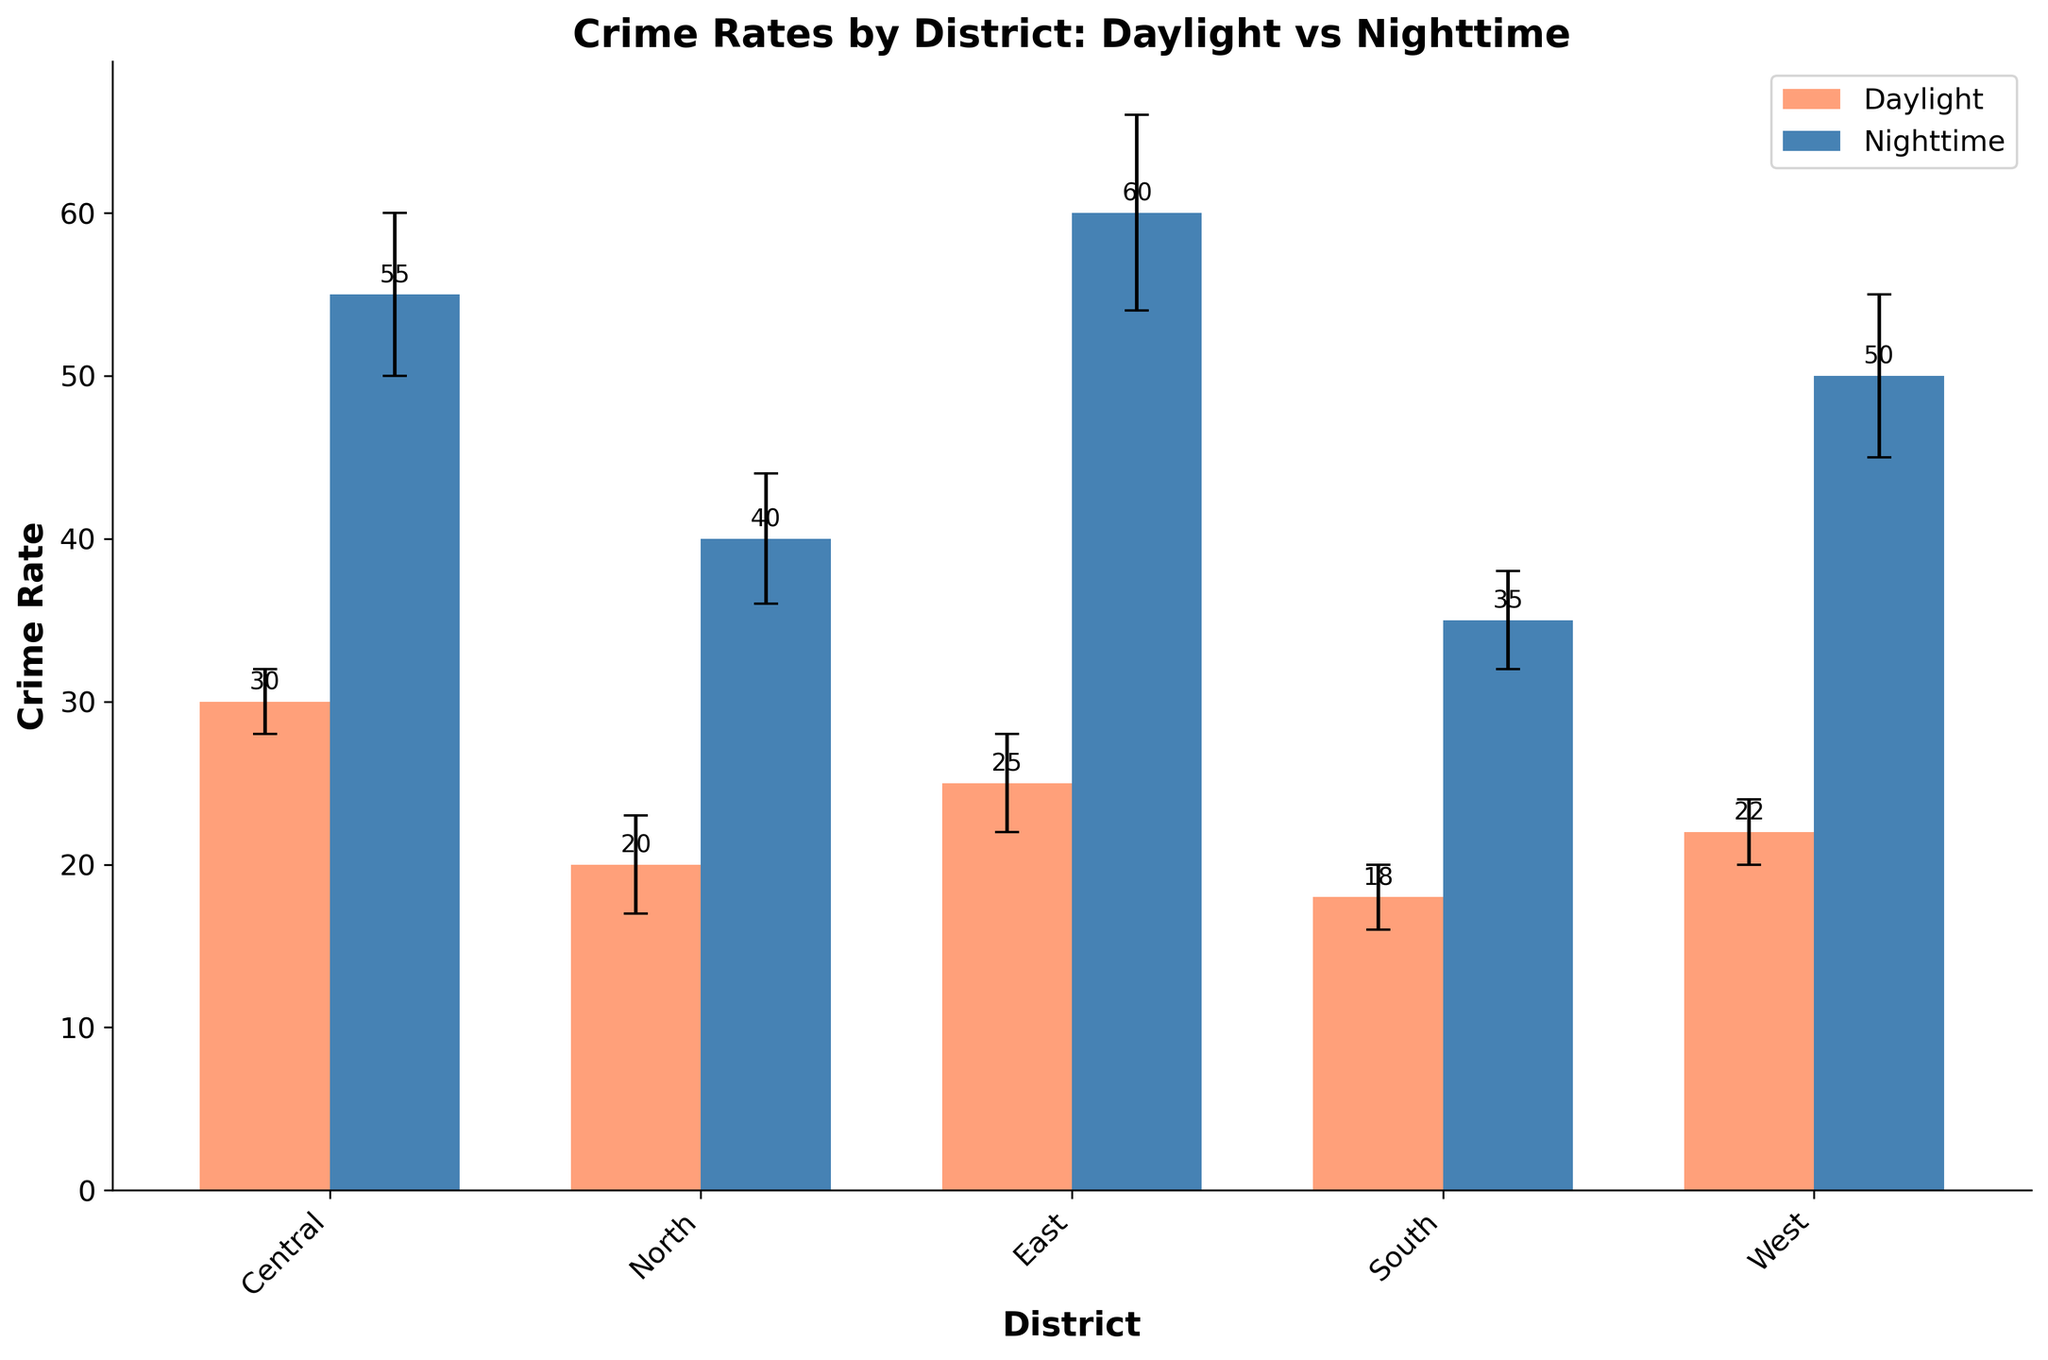What is the title of the plot? The title is often located at the top of the plot and summarizes the main objective of the data visualization. Here, it reads "Crime Rates by District: Daylight vs Nighttime".
Answer: Crime Rates by District: Daylight vs Nighttime Which district has the highest nighttime crime rate? To find the district with the highest nighttime crime rate, look at the tallest blue bar. The highest blue bar corresponds to the East district with a crime rate of 60.
Answer: East What is the range of error for the daytime crime rate in the West district? The error range for each bar can be seen by examining the error bars extending above and below the top of the bar. For the West district during the day, the error is ±2.
Answer: ±2 How many districts have higher nighttime crime rates compared to daylight crime rates? To determine the number of districts with higher nighttime crime rates, compare each pair of orange and blue bars. All districts (Central, North, East, South, and West) have higher nighttime rates.
Answer: 5 What is the total crime rate for the Central district, combining both day and night? Sum the crime rates for the Central district during the day and night: 30 (daylight) + 55 (nighttime) = 85.
Answer: 85 Which district has the smallest difference between daylight and nighttime crime rates? Calculate the differences between the day and night crime rates for all districts and find the smallest difference. For North: 40-20=20, for Central: 55-30=25, for South: 35-18=17, for East: 60-25=35, and for West: 50-22=28. The South district has the smallest difference of 17.
Answer: South Among the districts, which one has the highest error in nighttime crime rates? Look at the length of the error bars for the nighttime crime rates (blue bars) and compare them. The East district has the highest error of ±6.
Answer: East What is the average crime rate during the daytime across all districts? Calculate the average of the daytime crime rates: (30 + 20 + 25 + 18 + 22) / 5 = 115 / 5 = 23.
Answer: 23 Which has a higher average crime rate, daytime or nighttime? Compare the average daytime and nighttime crime rates. Calculate daytime: (30+20+25+18+22)/5=23. Calculate nighttime: (55+40+60+35+50)/5=48. Nighttime has a higher average.
Answer: Nighttime 